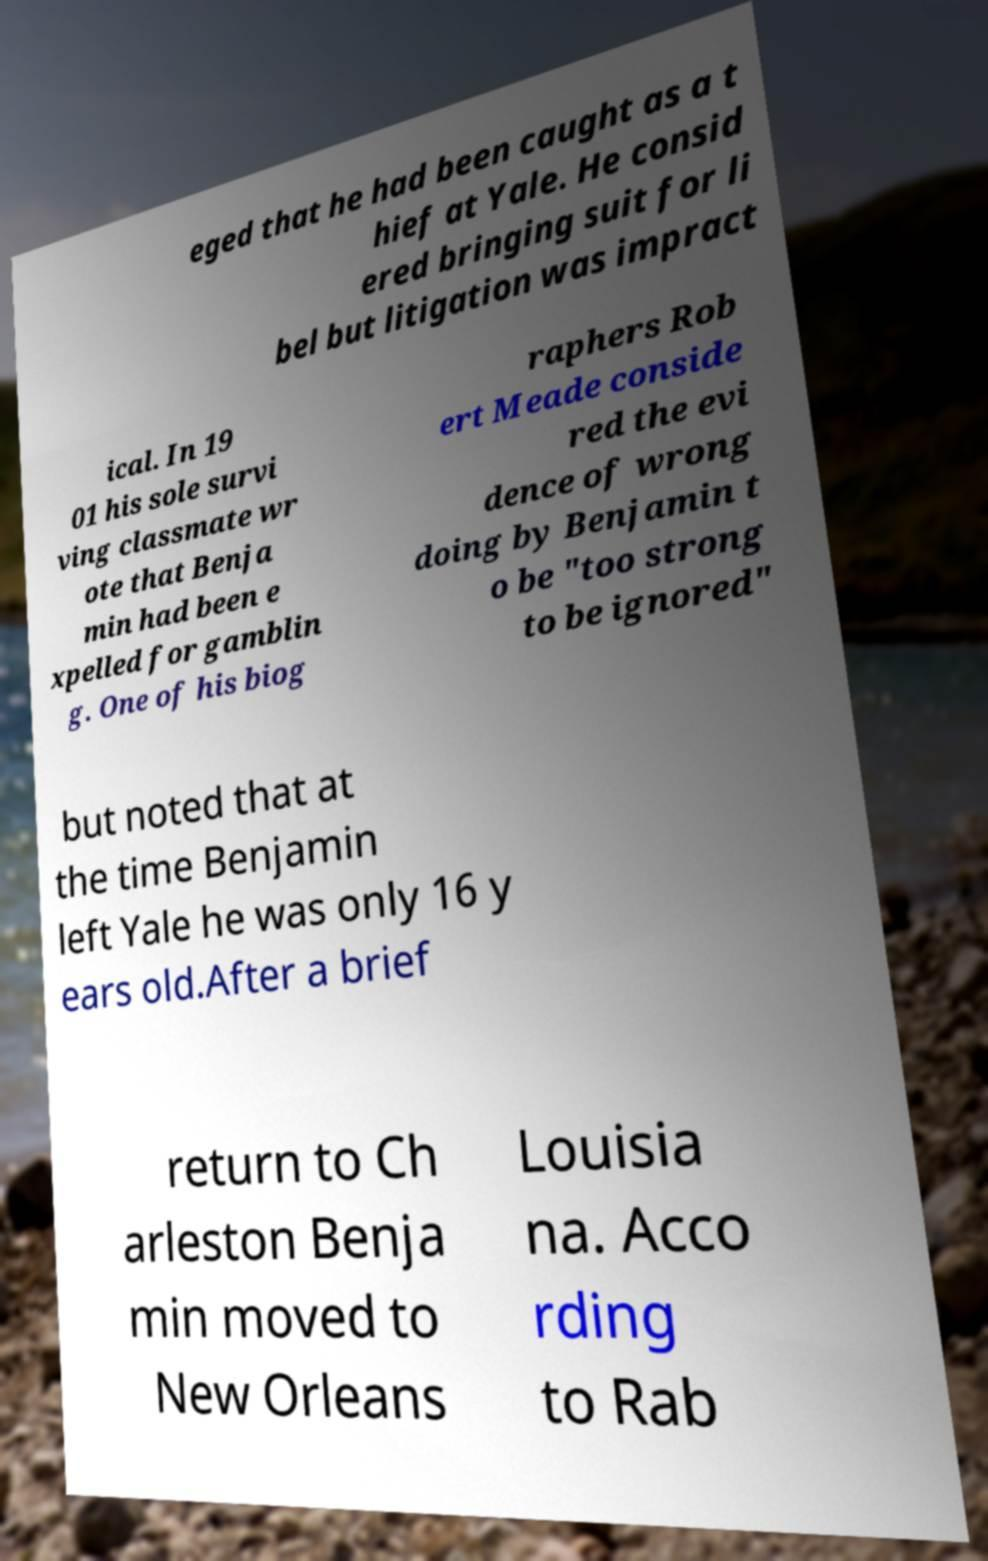There's text embedded in this image that I need extracted. Can you transcribe it verbatim? eged that he had been caught as a t hief at Yale. He consid ered bringing suit for li bel but litigation was impract ical. In 19 01 his sole survi ving classmate wr ote that Benja min had been e xpelled for gamblin g. One of his biog raphers Rob ert Meade conside red the evi dence of wrong doing by Benjamin t o be "too strong to be ignored" but noted that at the time Benjamin left Yale he was only 16 y ears old.After a brief return to Ch arleston Benja min moved to New Orleans Louisia na. Acco rding to Rab 